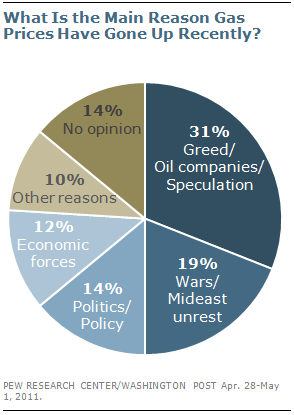Give some essential details in this illustration. I hold the opinion that 14% is the answer, but I do not have a strong opinion either way. According to the survey, other reasons and economic force are estimated to be approximately 10% and 12% of the total response, respectively. 